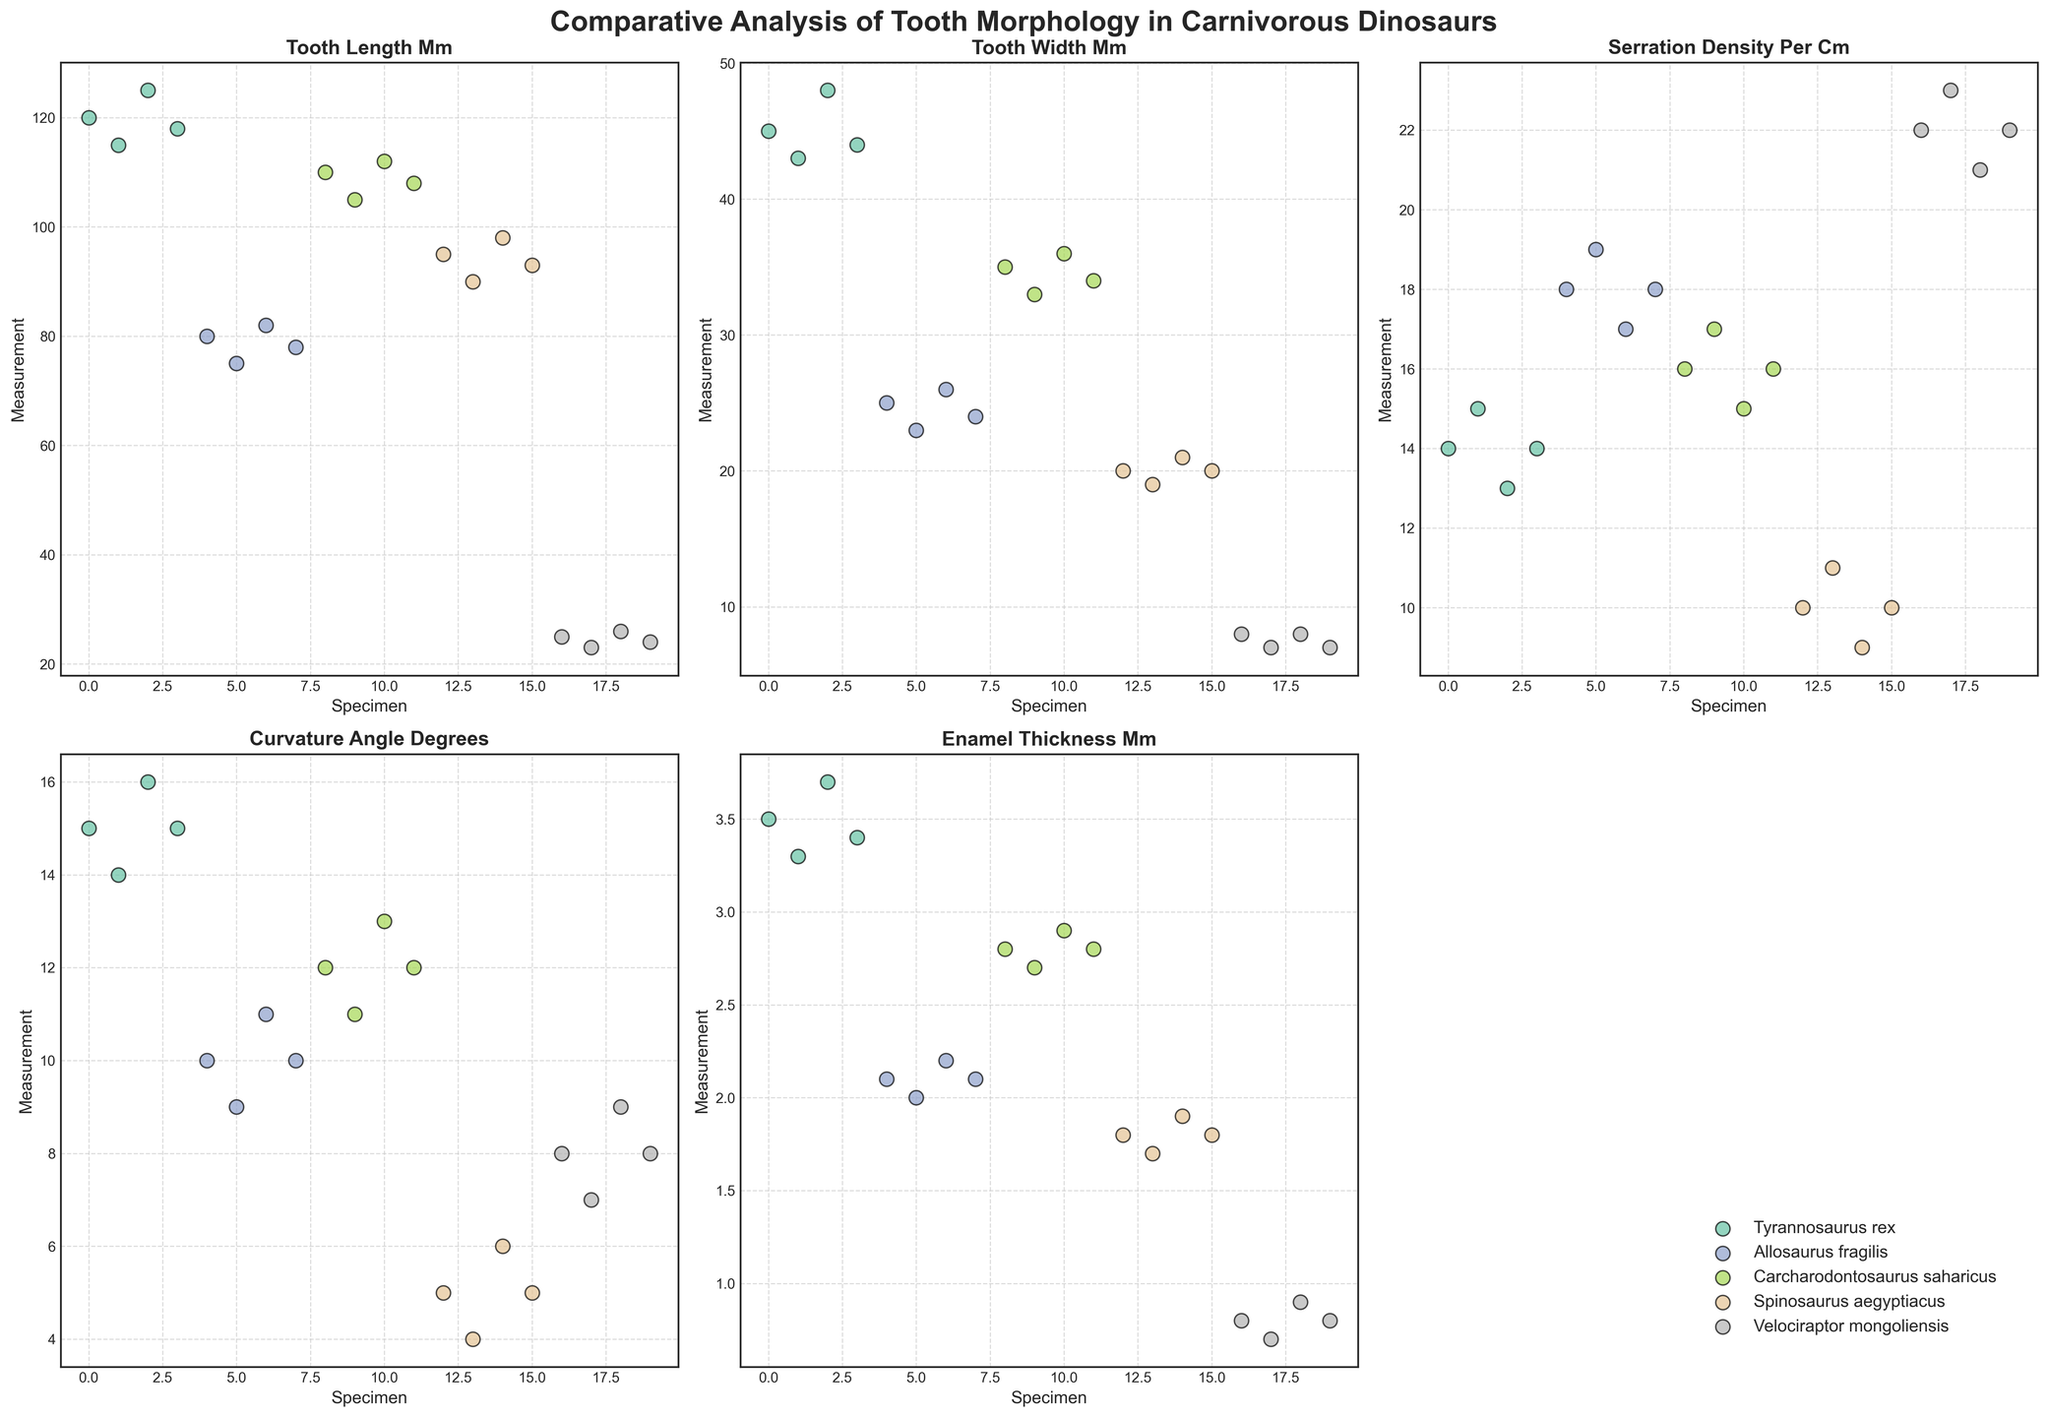Which species has the highest average tooth length? By examining the scatter plots of tooth lengths, we can compare the average values for each species. The Tyrannosaurus rex specimens exhibit consistently higher tooth lengths.
Answer: Tyrannosaurus rex What is the difference in average tooth serration density between Allosaurus fragilis and Velociraptor mongoliensis? By looking at the serration density subplot, we can calculate the average serration density for each species and then find the difference. The average serration density for Allosaurus fragilis is around 18, while for Velociraptor mongoliensis, it is around 22. The difference is, therefore, 22 - 18 = 4.
Answer: 4 Which species exhibit the most diverse range in tooth curvature angle? Assessing the scatter plot for tooth curvature angles, we observe that Tyrannosaurus rex shows a wide spread in curvature angle values from 14 to 16 degrees, indicating a diverse range.
Answer: Tyrannosaurus rex Which species has the thinnest enamel on average? By reviewing the enamel thickness subplot, it is apparent that Velociraptor mongoliensis has the thinnest enamel on average, with values around 0.8 mm.
Answer: Velociraptor mongoliensis What is the ratio of the average tooth length of Tyrannosaurus rex to the average tooth length of Spinosaurus aegyptiacus? The average tooth length for Tyrannosaurus rex is around 119.5 mm, and for Spinosaurus aegyptiacus, it is around 94 mm. The ratio is 119.5 / 94 ≈ 1.27.
Answer: 1.27 Among all the species, which has the highest variance in tooth width measurements? Analyzing the tooth width subplot, Allosaurus fragilis appears to exhibit a fair spread in its scatter plot, suggesting a high variance in tooth width values.
Answer: Allosaurus fragilis Which dinosaur species has consistently higher serration densities compared to Spinosaurus aegyptiacus? By examining the serration density subplot, Velociraptor mongoliensis consistently shows a higher serration density than Spinosaurus aegyptiacus.
Answer: Velociraptor mongoliensis What is the average curvature angle for Carcharodontosaurus saharicus specimens? Looking at the subplot for curvature angles, the values for Carcharodontosaurus saharicus are 12, 11, 13, and 12 degrees. The average is (12 + 11 + 13 + 12) / 4 = 12 degrees.
Answer: 12 degrees Compare the enamel thickness in Tyrannosaurus rex to that of Spinosaurus aegyptiacus. The enamel thickness subplot shows that Tyrannosaurus rex has enamel thickness values around 3.5 mm, which are higher than those of Spinosaurus aegyptiacus (around 1.8 mm).
Answer: Tyrannosaurus rex has thicker enamel If we combine the tooth lengths of Allosaurus fragilis and Carcharodontosaurus saharicus, what would be their average? Summing up the tooth lengths: Allosaurus fragilis (80 + 75 + 82 + 78 = 315) and Carcharodontosaurus saharicus (110 + 105 + 112 + 108 = 435). The combined sum is 315 + 435 = 750, and the total number of specimens is 8. The average is 750 / 8 ≈ 93.75 mm.
Answer: 93.75 mm 